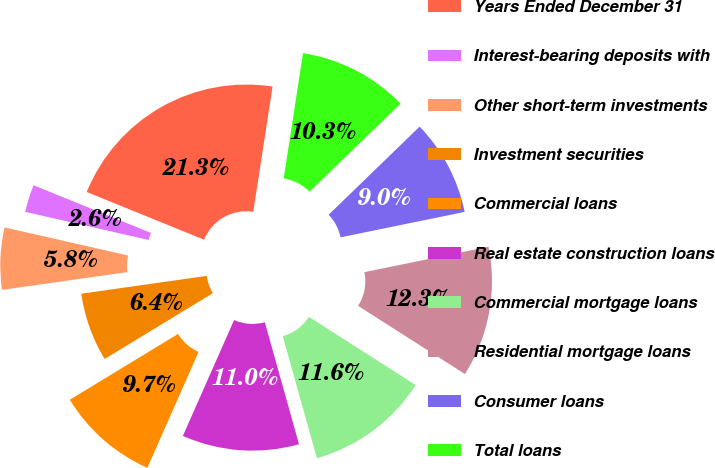Convert chart to OTSL. <chart><loc_0><loc_0><loc_500><loc_500><pie_chart><fcel>Years Ended December 31<fcel>Interest-bearing deposits with<fcel>Other short-term investments<fcel>Investment securities<fcel>Commercial loans<fcel>Real estate construction loans<fcel>Commercial mortgage loans<fcel>Residential mortgage loans<fcel>Consumer loans<fcel>Total loans<nl><fcel>21.29%<fcel>2.58%<fcel>5.81%<fcel>6.45%<fcel>9.68%<fcel>10.97%<fcel>11.61%<fcel>12.26%<fcel>9.03%<fcel>10.32%<nl></chart> 